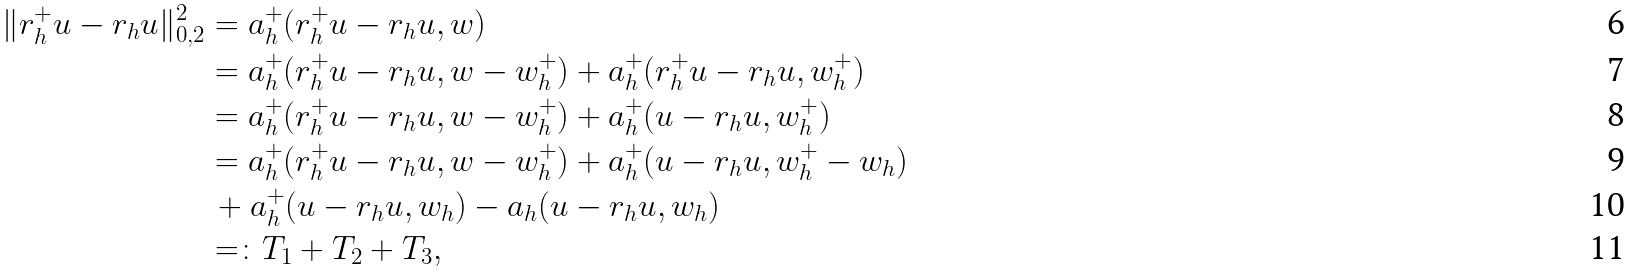Convert formula to latex. <formula><loc_0><loc_0><loc_500><loc_500>\| r _ { h } ^ { + } u - r _ { h } u \| _ { 0 , 2 } ^ { 2 } & = a _ { h } ^ { + } ( r _ { h } ^ { + } u - r _ { h } u , w ) \\ & = a _ { h } ^ { + } ( r _ { h } ^ { + } u - r _ { h } u , w - w _ { h } ^ { + } ) + a _ { h } ^ { + } ( r _ { h } ^ { + } u - r _ { h } u , w _ { h } ^ { + } ) \\ & = a _ { h } ^ { + } ( r _ { h } ^ { + } u - r _ { h } u , w - w _ { h } ^ { + } ) + a _ { h } ^ { + } ( u - r _ { h } u , w _ { h } ^ { + } ) \\ & = a _ { h } ^ { + } ( r _ { h } ^ { + } u - r _ { h } u , w - w _ { h } ^ { + } ) + a _ { h } ^ { + } ( u - r _ { h } u , w _ { h } ^ { + } - w _ { h } ) \\ & \, + a _ { h } ^ { + } ( u - r _ { h } u , w _ { h } ) - a _ { h } ( u - r _ { h } u , w _ { h } ) \\ & = \colon T _ { 1 } + T _ { 2 } + T _ { 3 } ,</formula> 